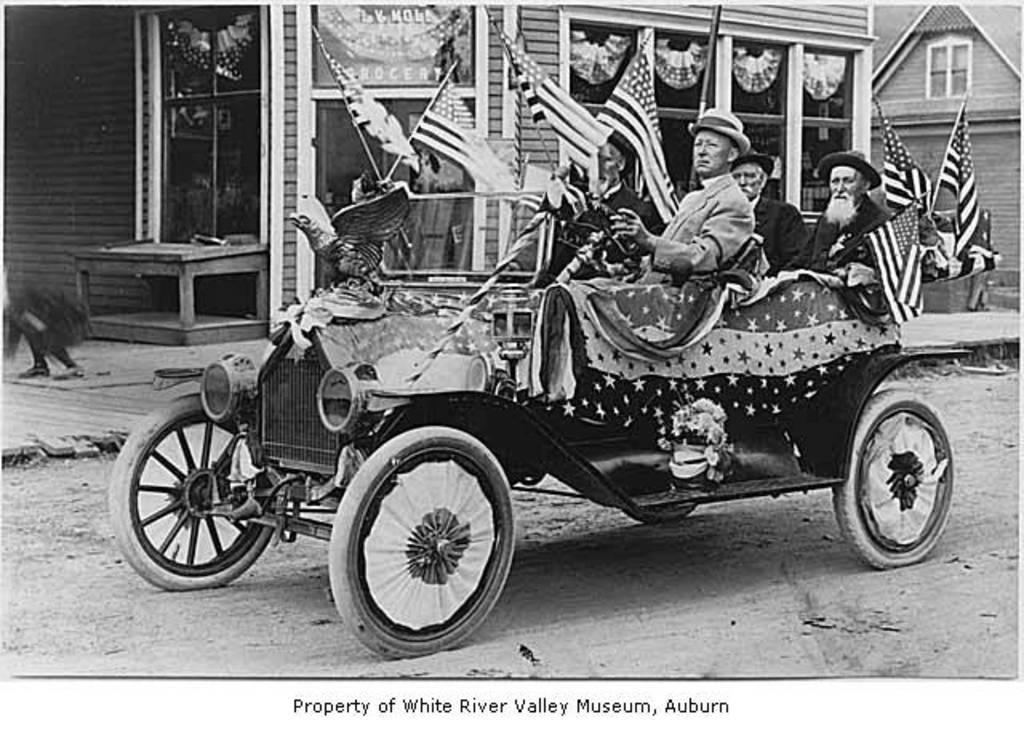What is the main subject of the image? There is a car in the image. How many people are inside the car? Four members are sitting in the car. What can be seen in the background of the image? There are two houses in the background of the image. What type of fact is being tested by the organization in the image? There is no mention of a fact, test, or organization in the image; it only features a car with four people inside and two houses in the background. 